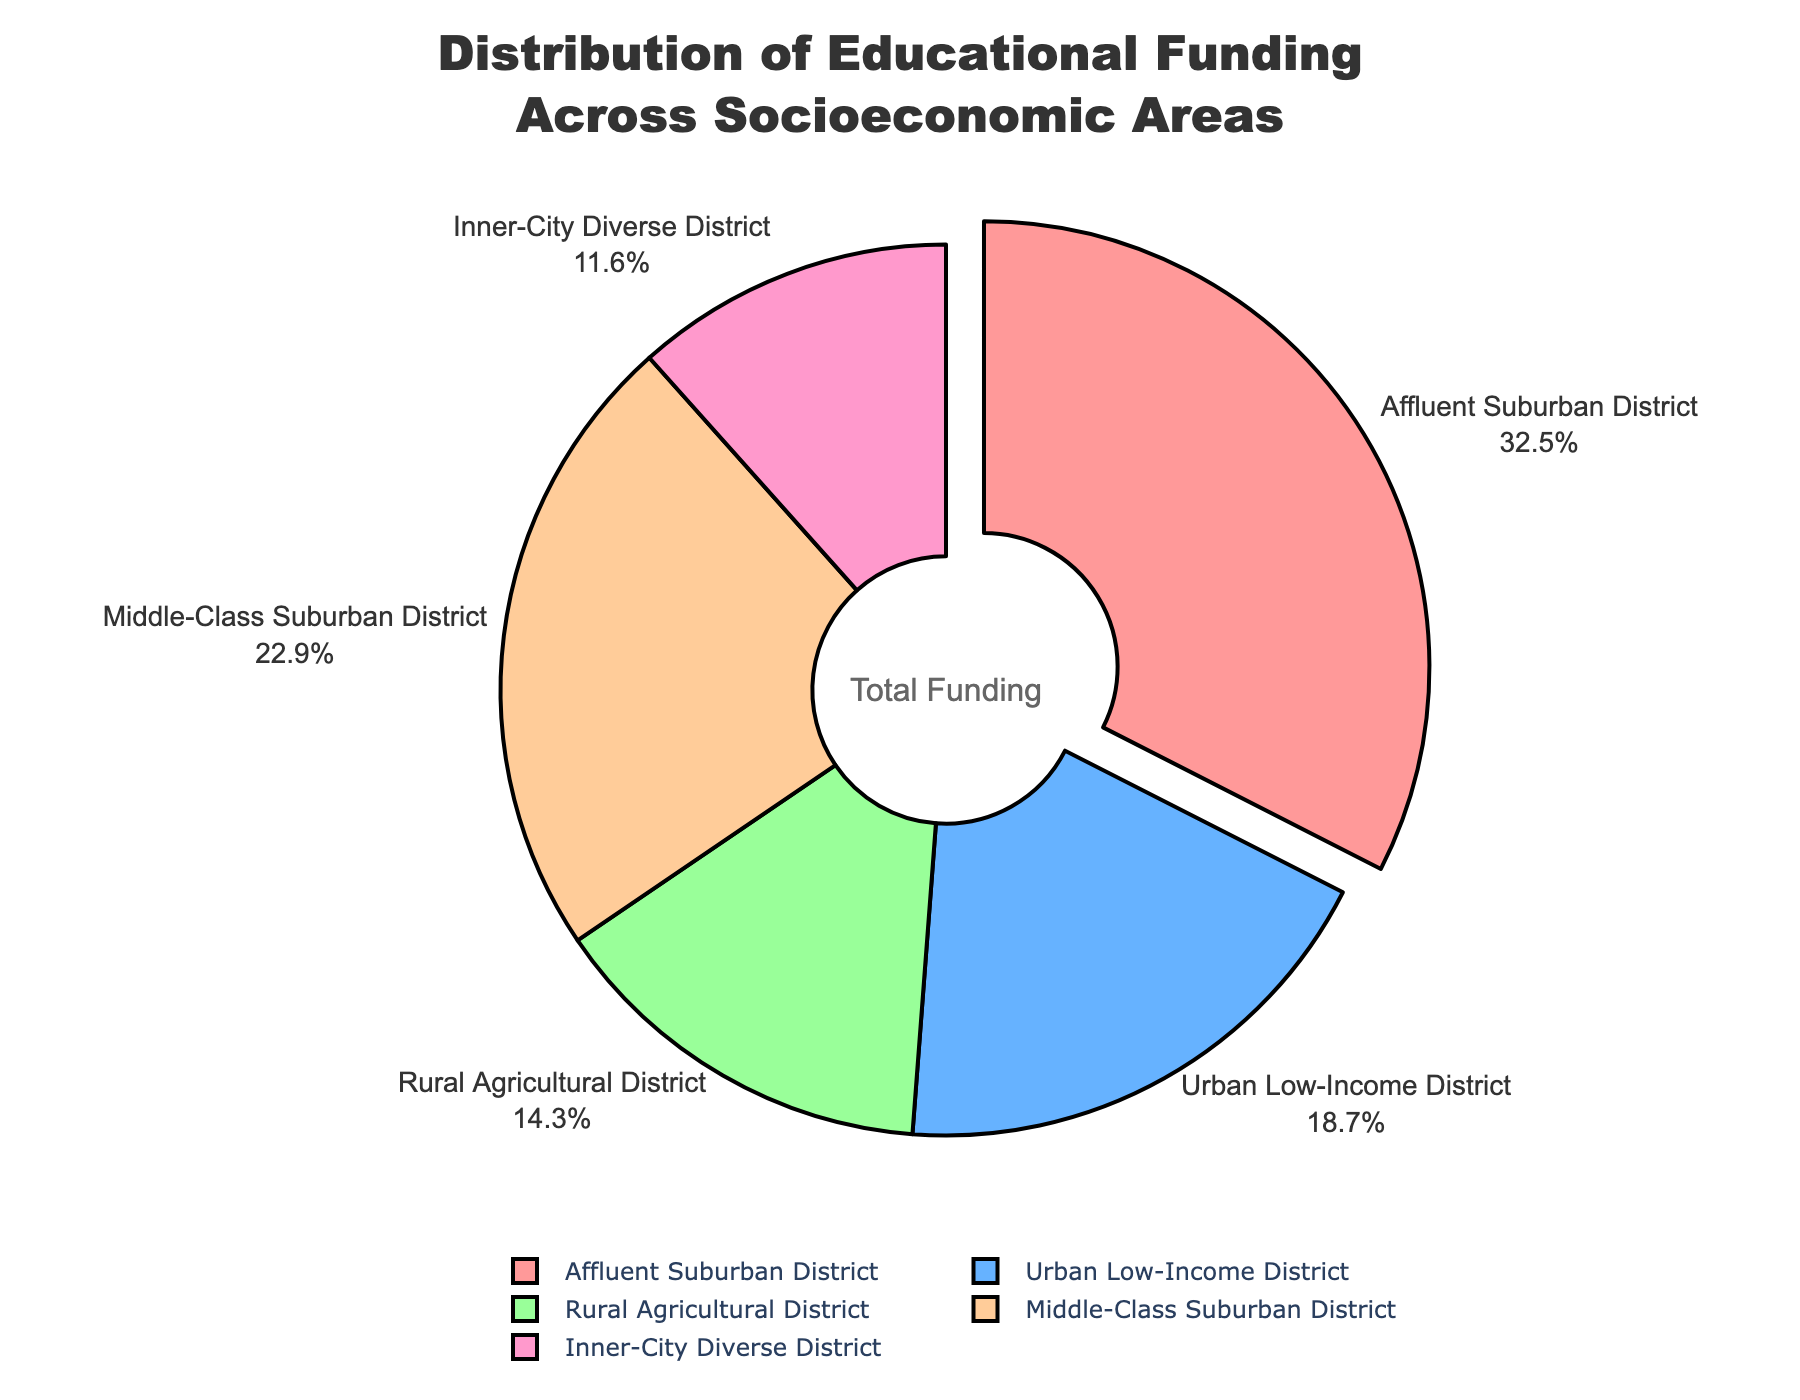Which district receives the highest percentage of funding? Look at the pie chart and identify the district with the largest slice. The "Affluent Suburban District" has the largest slice, indicating it receives the highest percentage of funding.
Answer: Affluent Suburban District Which district receives the smallest percentage of funding? Identify the district with the smallest slice in the pie chart. The "Inner-City Diverse District" has the smallest slice.
Answer: Inner-City Diverse District What is the combined percentage of funding for the Urban Low-Income District and Inner-City Diverse District? Add the percentages of the Urban Low-Income District (18.7%) and Inner-City Diverse District (11.6%). 18.7% + 11.6% = 30.3%
Answer: 30.3% How much greater is the funding percentage for the Affluent Suburban District compared to the Rural Agricultural District? Subtract the percentage of the Rural Agricultural District (14.3%) from the percentage of the Affluent Suburban District (32.5%). 32.5% - 14.3% = 18.2%
Answer: 18.2% Among the districts, which two have the closest funding percentages? Compare the funding percentages to identify the pair with the smallest difference. The Middle-Class Suburban District (22.9%) and Urban Low-Income District (18.7%) have a difference of 4.2%, which is the smallest.
Answer: Middle-Class Suburban District and Urban Low-Income District How does the percentage of funding for the Middle-Class Suburban District compare to the Urban Low-Income District? Compare the funding percentages of the Middle-Class Suburban District (22.9%) and Urban Low-Income District (18.7%). The Middle-Class Suburban District has a higher percentage.
Answer: Higher What fraction of the total funding is allocated to the Rural Agricultural District? Divide the percentage of the Rural Agricultural District (14.3%) by 100 to convert it to a fraction. 14.3/100 = 0.143
Answer: 0.143 Which color represents the Rural Agricultural District in the pie chart? Identify the color used for the Rural Agricultural District in the pie chart. The color is green.
Answer: Green What is the average funding percentage across all districts? Add up all the percentages (32.5% + 18.7% + 14.3% + 22.9% + 11.6% = 100%) and divide by the number of districts (5). 100/5 = 20%
Answer: 20% Which district's slice is "pulled out" from the pie chart? Look at the visual element of the pie chart to see which slice is pulled out. The "Affluent Suburban District" slice is pulled out.
Answer: Affluent Suburban District 